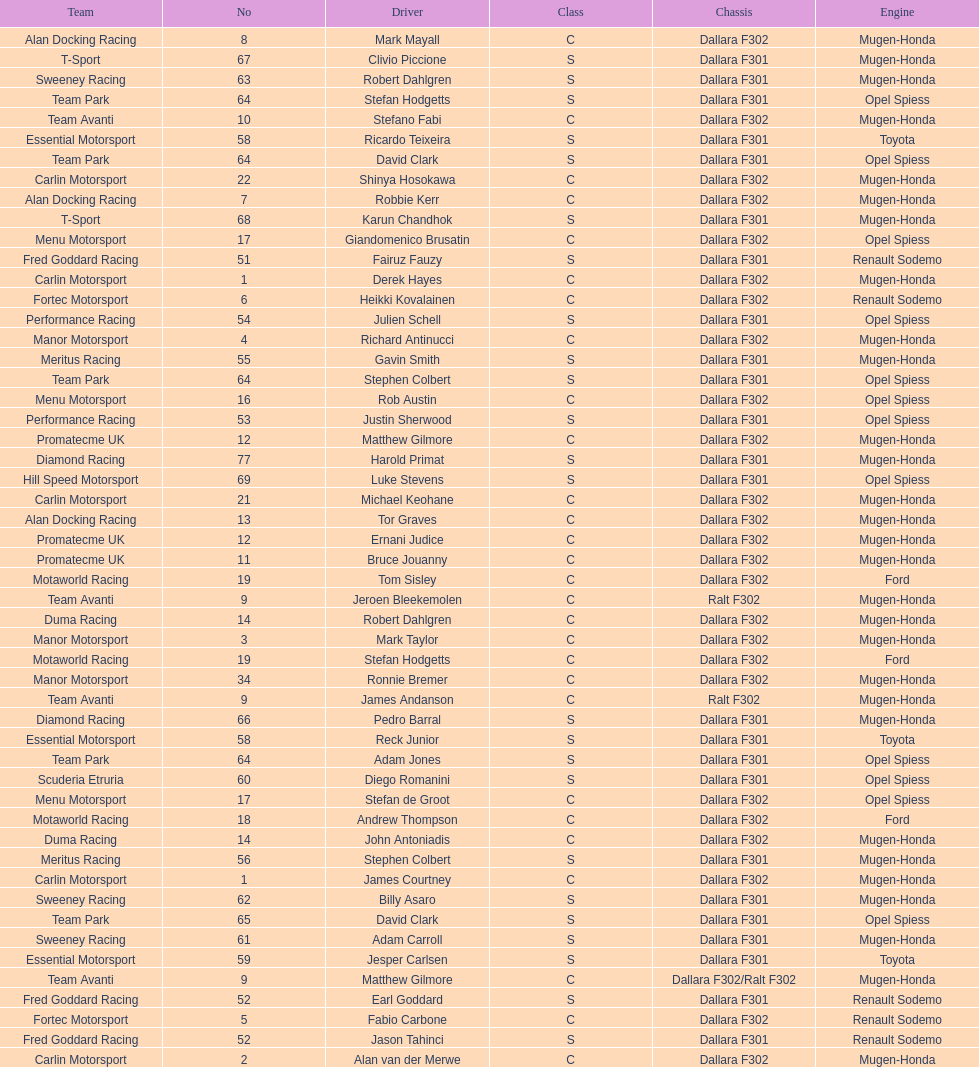Which engine was used the most by teams this season? Mugen-Honda. 